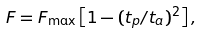Convert formula to latex. <formula><loc_0><loc_0><loc_500><loc_500>F = F _ { \max } \left [ 1 - ( t _ { p } / t _ { a } ) ^ { 2 } \right ] ,</formula> 